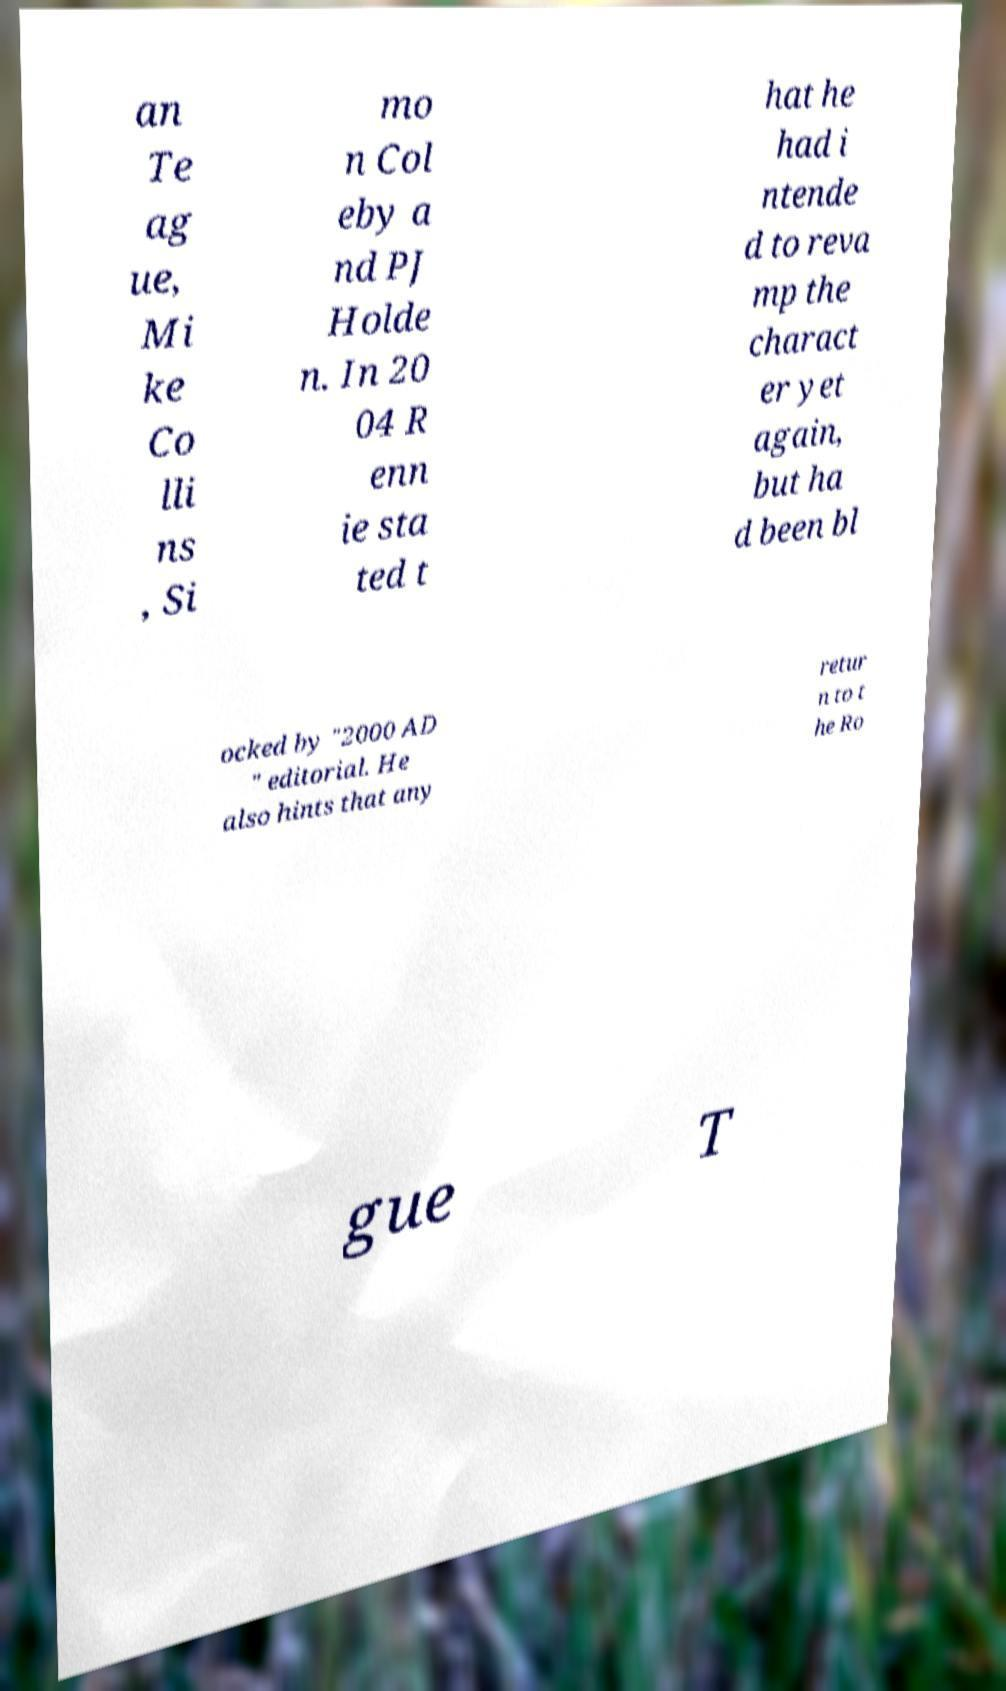What messages or text are displayed in this image? I need them in a readable, typed format. an Te ag ue, Mi ke Co lli ns , Si mo n Col eby a nd PJ Holde n. In 20 04 R enn ie sta ted t hat he had i ntende d to reva mp the charact er yet again, but ha d been bl ocked by "2000 AD " editorial. He also hints that any retur n to t he Ro gue T 